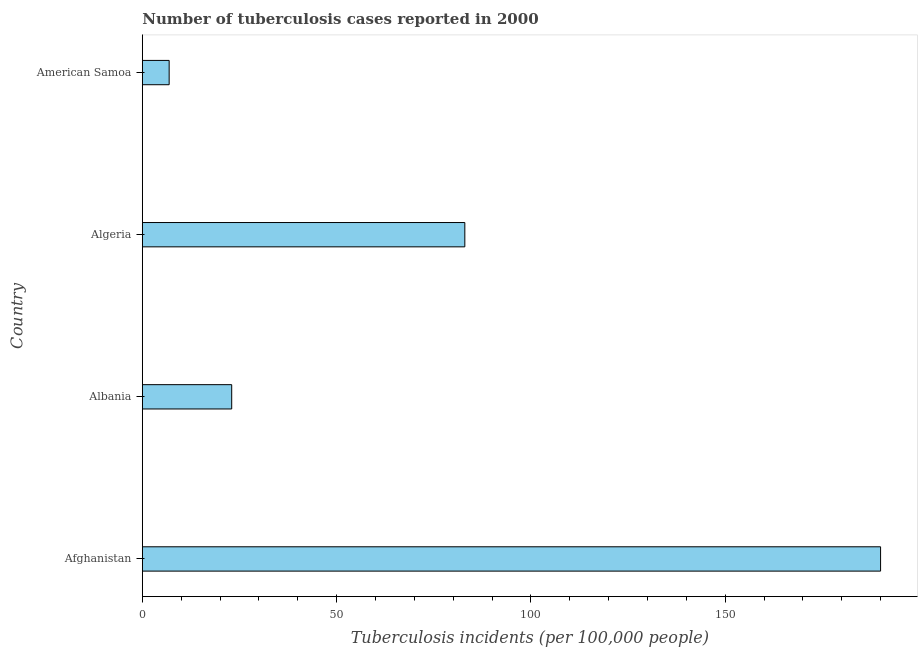Does the graph contain grids?
Your answer should be very brief. No. What is the title of the graph?
Your answer should be very brief. Number of tuberculosis cases reported in 2000. What is the label or title of the X-axis?
Make the answer very short. Tuberculosis incidents (per 100,0 people). Across all countries, what is the maximum number of tuberculosis incidents?
Make the answer very short. 190. Across all countries, what is the minimum number of tuberculosis incidents?
Your response must be concise. 6.9. In which country was the number of tuberculosis incidents maximum?
Your response must be concise. Afghanistan. In which country was the number of tuberculosis incidents minimum?
Offer a very short reply. American Samoa. What is the sum of the number of tuberculosis incidents?
Offer a very short reply. 302.9. What is the difference between the number of tuberculosis incidents in Afghanistan and Algeria?
Give a very brief answer. 107. What is the average number of tuberculosis incidents per country?
Offer a very short reply. 75.72. What is the median number of tuberculosis incidents?
Keep it short and to the point. 53. What is the ratio of the number of tuberculosis incidents in Afghanistan to that in Algeria?
Make the answer very short. 2.29. Is the difference between the number of tuberculosis incidents in Afghanistan and Albania greater than the difference between any two countries?
Keep it short and to the point. No. What is the difference between the highest and the second highest number of tuberculosis incidents?
Provide a short and direct response. 107. What is the difference between the highest and the lowest number of tuberculosis incidents?
Give a very brief answer. 183.1. In how many countries, is the number of tuberculosis incidents greater than the average number of tuberculosis incidents taken over all countries?
Provide a short and direct response. 2. What is the difference between two consecutive major ticks on the X-axis?
Provide a succinct answer. 50. Are the values on the major ticks of X-axis written in scientific E-notation?
Your answer should be very brief. No. What is the Tuberculosis incidents (per 100,000 people) of Afghanistan?
Your answer should be very brief. 190. What is the Tuberculosis incidents (per 100,000 people) of American Samoa?
Your answer should be very brief. 6.9. What is the difference between the Tuberculosis incidents (per 100,000 people) in Afghanistan and Albania?
Offer a terse response. 167. What is the difference between the Tuberculosis incidents (per 100,000 people) in Afghanistan and Algeria?
Your response must be concise. 107. What is the difference between the Tuberculosis incidents (per 100,000 people) in Afghanistan and American Samoa?
Offer a very short reply. 183.1. What is the difference between the Tuberculosis incidents (per 100,000 people) in Albania and Algeria?
Your answer should be very brief. -60. What is the difference between the Tuberculosis incidents (per 100,000 people) in Albania and American Samoa?
Your response must be concise. 16.1. What is the difference between the Tuberculosis incidents (per 100,000 people) in Algeria and American Samoa?
Your response must be concise. 76.1. What is the ratio of the Tuberculosis incidents (per 100,000 people) in Afghanistan to that in Albania?
Your response must be concise. 8.26. What is the ratio of the Tuberculosis incidents (per 100,000 people) in Afghanistan to that in Algeria?
Offer a terse response. 2.29. What is the ratio of the Tuberculosis incidents (per 100,000 people) in Afghanistan to that in American Samoa?
Ensure brevity in your answer.  27.54. What is the ratio of the Tuberculosis incidents (per 100,000 people) in Albania to that in Algeria?
Provide a succinct answer. 0.28. What is the ratio of the Tuberculosis incidents (per 100,000 people) in Albania to that in American Samoa?
Your answer should be compact. 3.33. What is the ratio of the Tuberculosis incidents (per 100,000 people) in Algeria to that in American Samoa?
Ensure brevity in your answer.  12.03. 